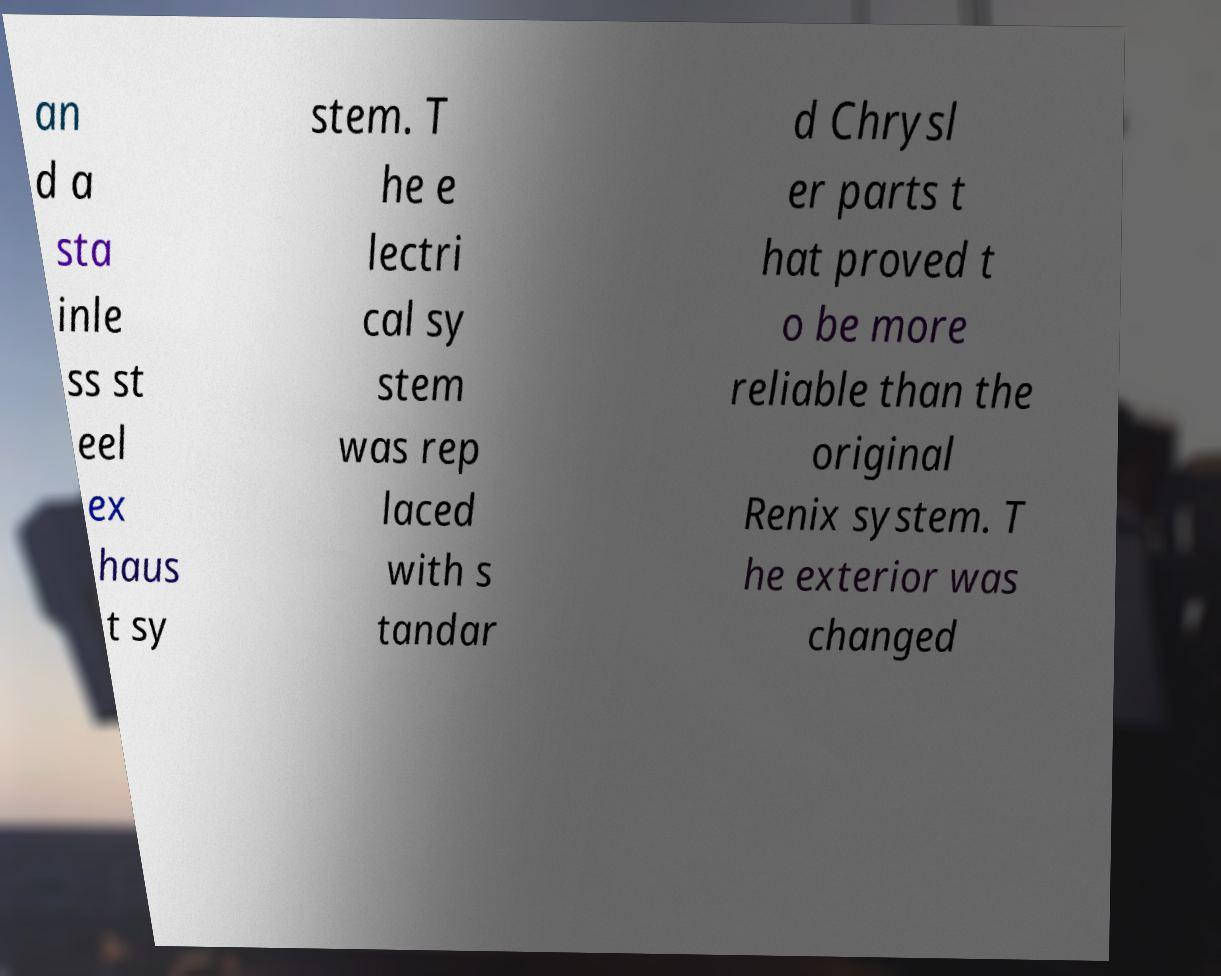Can you read and provide the text displayed in the image?This photo seems to have some interesting text. Can you extract and type it out for me? an d a sta inle ss st eel ex haus t sy stem. T he e lectri cal sy stem was rep laced with s tandar d Chrysl er parts t hat proved t o be more reliable than the original Renix system. T he exterior was changed 